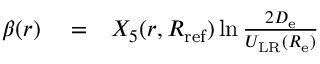Convert formula to latex. <formula><loc_0><loc_0><loc_500><loc_500>\begin{array} { r l r } { \beta ( r ) } & = } & { X _ { 5 } ( r , R _ { r e f } ) \ln \frac { 2 D _ { e } } { U _ { L R } ( R _ { e } ) } } \end{array}</formula> 